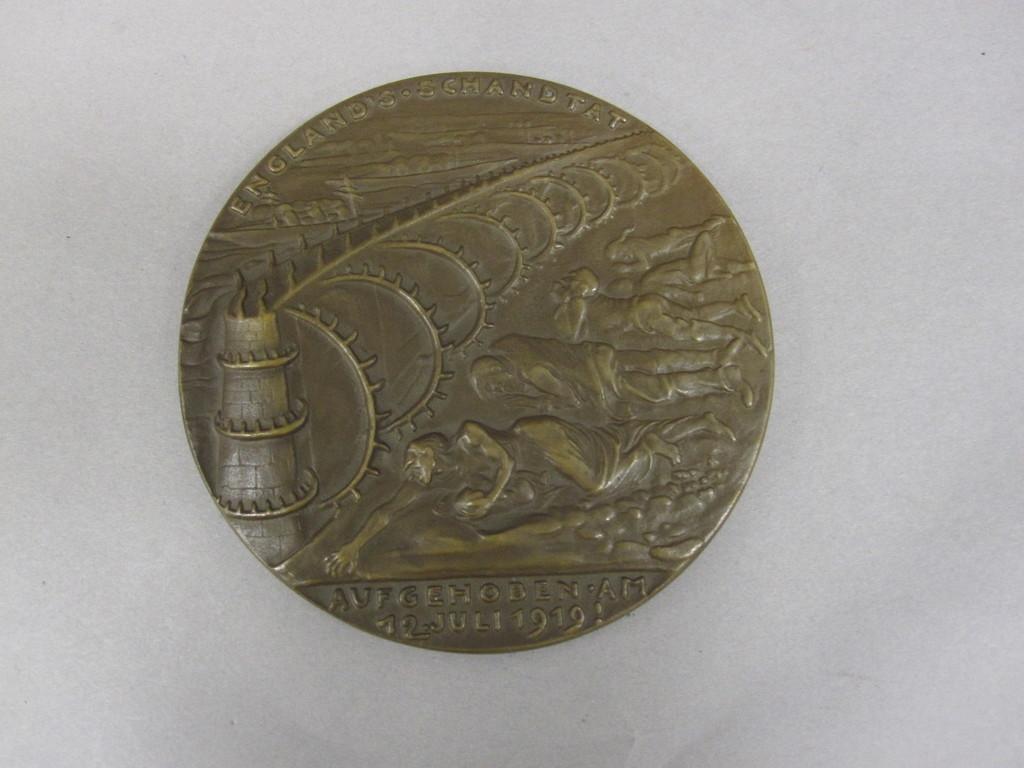What is the date on the coin?
Your response must be concise. 1919. 